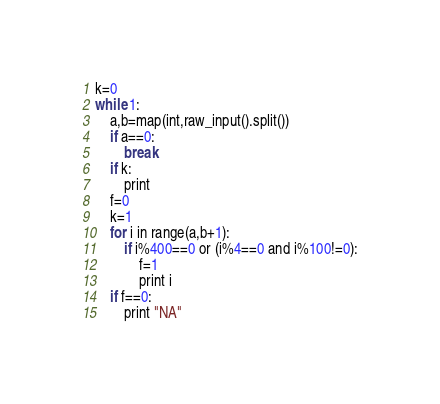Convert code to text. <code><loc_0><loc_0><loc_500><loc_500><_Python_>k=0
while 1:
    a,b=map(int,raw_input().split())
    if a==0:
        break
    if k:
        print
    f=0
    k=1
    for i in range(a,b+1):
        if i%400==0 or (i%4==0 and i%100!=0):
            f=1
            print i
    if f==0:
        print "NA"</code> 